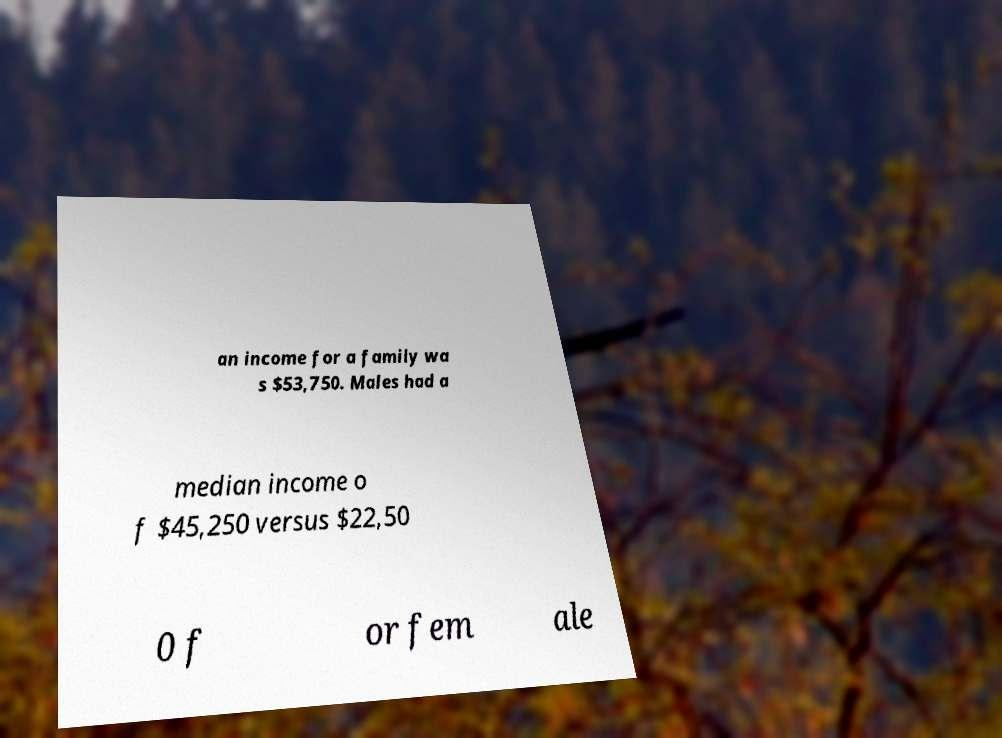Could you extract and type out the text from this image? an income for a family wa s $53,750. Males had a median income o f $45,250 versus $22,50 0 f or fem ale 